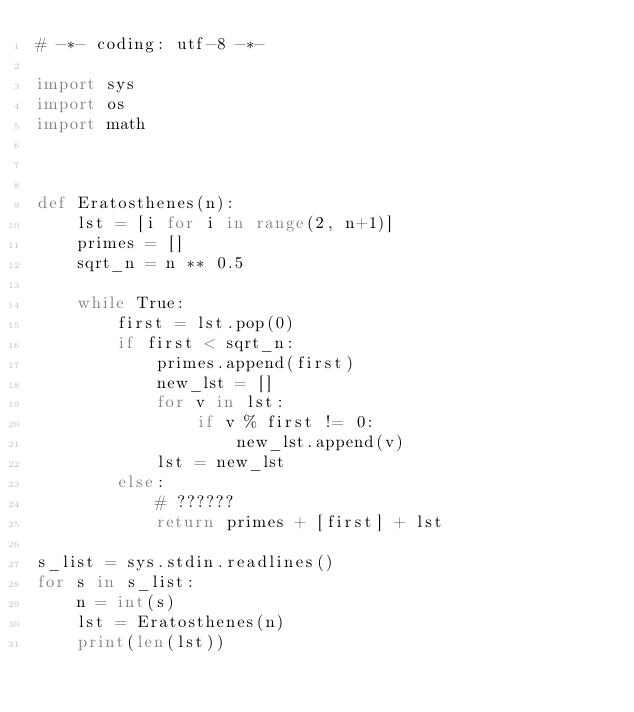<code> <loc_0><loc_0><loc_500><loc_500><_Python_># -*- coding: utf-8 -*-

import sys
import os
import math



def Eratosthenes(n):
    lst = [i for i in range(2, n+1)]
    primes = []
    sqrt_n = n ** 0.5

    while True:
        first = lst.pop(0)
        if first < sqrt_n:
            primes.append(first)
            new_lst = []
            for v in lst:
                if v % first != 0:
                    new_lst.append(v)
            lst = new_lst
        else:
            # ??????
            return primes + [first] + lst

s_list = sys.stdin.readlines()
for s in s_list:
    n = int(s)
    lst = Eratosthenes(n)
    print(len(lst))</code> 